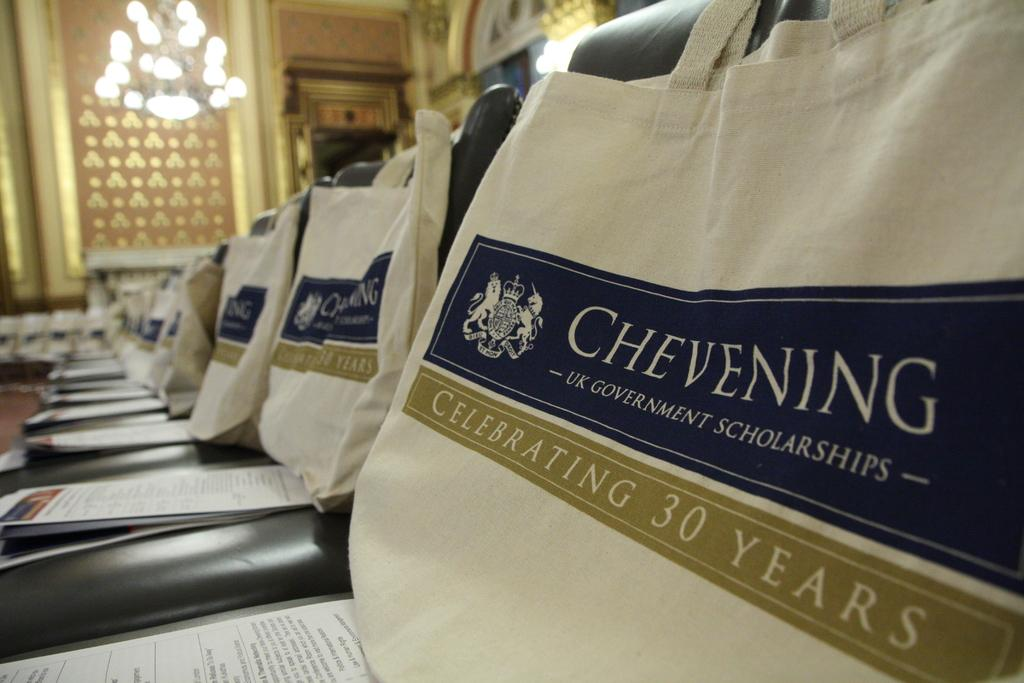<image>
Present a compact description of the photo's key features. Multiple bags and pamphlets  from the brand Chevening are on top of chairs. 